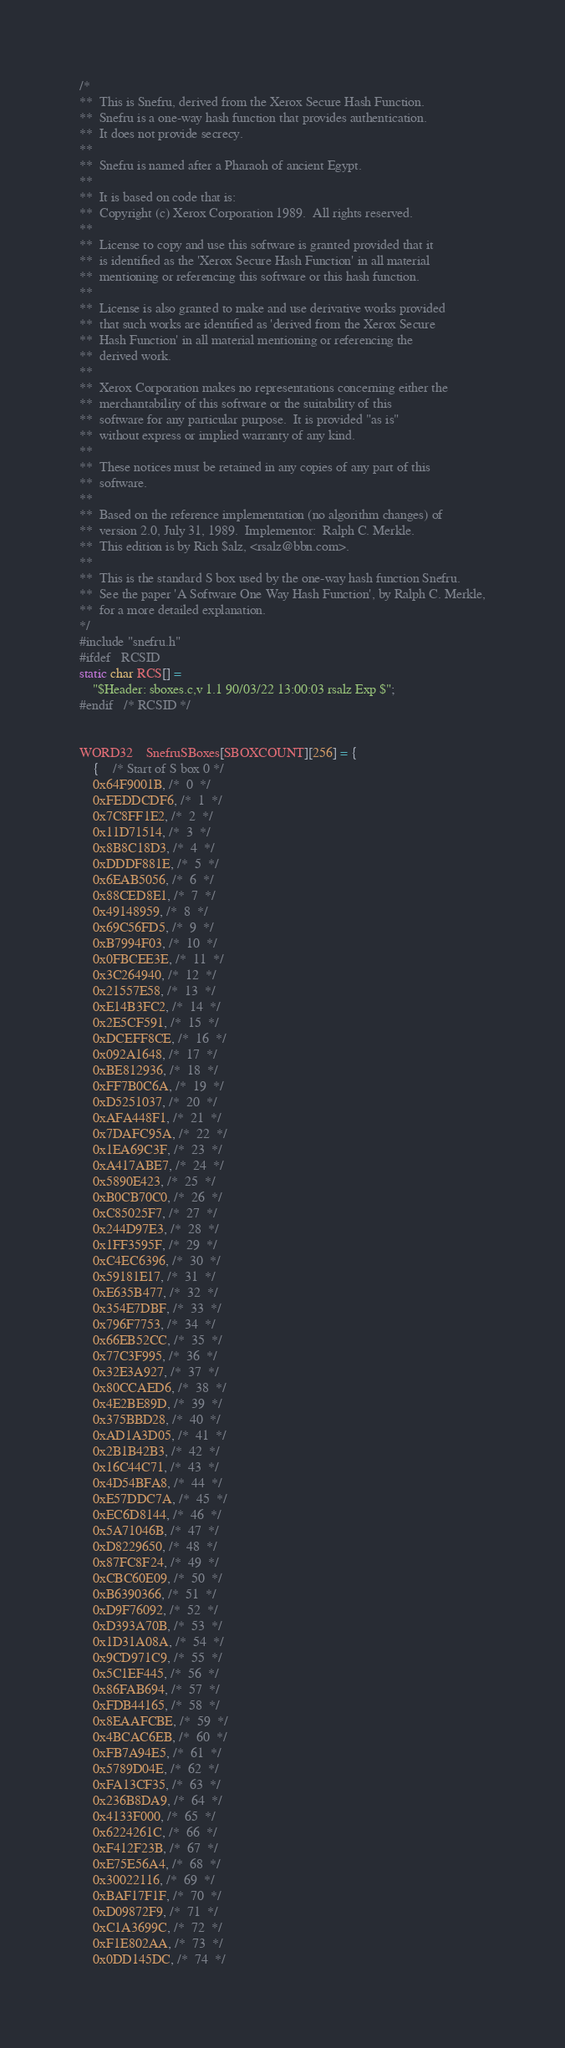<code> <loc_0><loc_0><loc_500><loc_500><_C_>/*
**  This is Snefru, derived from the Xerox Secure Hash Function.
**  Snefru is a one-way hash function that provides authentication.
**  It does not provide secrecy.
**
**  Snefru is named after a Pharaoh of ancient Egypt.
**
**  It is based on code that is:
**	Copyright (c) Xerox Corporation 1989.  All rights reserved.
**
**	License to copy and use this software is granted provided that it
**	is identified as the 'Xerox Secure Hash Function' in all material
**	mentioning or referencing this software or this hash function.
**
**	License is also granted to make and use derivative works provided
**	that such works are identified as 'derived from the Xerox Secure
**	Hash Function' in all material mentioning or referencing the
**	derived work.
**
**	Xerox Corporation makes no representations concerning either the
**	merchantability of this software or the suitability of this
**	software for any particular purpose.  It is provided "as is"
**	without express or implied warranty of any kind.
**
**	These notices must be retained in any copies of any part of this
**	software.
**
**  Based on the reference implementation (no algorithm changes) of
**  version 2.0, July 31, 1989.  Implementor:  Ralph C. Merkle.
**  This edition is by Rich $alz, <rsalz@bbn.com>.
**
**  This is the standard S box used by the one-way hash function Snefru.
**  See the paper 'A Software One Way Hash Function', by Ralph C. Merkle,
**  for a more detailed explanation.
*/
#include "snefru.h"
#ifdef	RCSID
static char RCS[] =
	"$Header: sboxes.c,v 1.1 90/03/22 13:00:03 rsalz Exp $";
#endif	/* RCSID */


WORD32	SnefruSBoxes[SBOXCOUNT][256] = {
    {	/* Start of S box 0 */
	0x64F9001B, /*  0  */
	0xFEDDCDF6, /*  1  */
	0x7C8FF1E2, /*  2  */
	0x11D71514, /*  3  */
	0x8B8C18D3, /*  4  */
	0xDDDF881E, /*  5  */
	0x6EAB5056, /*  6  */
	0x88CED8E1, /*  7  */
	0x49148959, /*  8  */
	0x69C56FD5, /*  9  */
	0xB7994F03, /*  10  */
	0x0FBCEE3E, /*  11  */
	0x3C264940, /*  12  */
	0x21557E58, /*  13  */
	0xE14B3FC2, /*  14  */
	0x2E5CF591, /*  15  */
	0xDCEFF8CE, /*  16  */
	0x092A1648, /*  17  */
	0xBE812936, /*  18  */
	0xFF7B0C6A, /*  19  */
	0xD5251037, /*  20  */
	0xAFA448F1, /*  21  */
	0x7DAFC95A, /*  22  */
	0x1EA69C3F, /*  23  */
	0xA417ABE7, /*  24  */
	0x5890E423, /*  25  */
	0xB0CB70C0, /*  26  */
	0xC85025F7, /*  27  */
	0x244D97E3, /*  28  */
	0x1FF3595F, /*  29  */
	0xC4EC6396, /*  30  */
	0x59181E17, /*  31  */
	0xE635B477, /*  32  */
	0x354E7DBF, /*  33  */
	0x796F7753, /*  34  */
	0x66EB52CC, /*  35  */
	0x77C3F995, /*  36  */
	0x32E3A927, /*  37  */
	0x80CCAED6, /*  38  */
	0x4E2BE89D, /*  39  */
	0x375BBD28, /*  40  */
	0xAD1A3D05, /*  41  */
	0x2B1B42B3, /*  42  */
	0x16C44C71, /*  43  */
	0x4D54BFA8, /*  44  */
	0xE57DDC7A, /*  45  */
	0xEC6D8144, /*  46  */
	0x5A71046B, /*  47  */
	0xD8229650, /*  48  */
	0x87FC8F24, /*  49  */
	0xCBC60E09, /*  50  */
	0xB6390366, /*  51  */
	0xD9F76092, /*  52  */
	0xD393A70B, /*  53  */
	0x1D31A08A, /*  54  */
	0x9CD971C9, /*  55  */
	0x5C1EF445, /*  56  */
	0x86FAB694, /*  57  */
	0xFDB44165, /*  58  */
	0x8EAAFCBE, /*  59  */
	0x4BCAC6EB, /*  60  */
	0xFB7A94E5, /*  61  */
	0x5789D04E, /*  62  */
	0xFA13CF35, /*  63  */
	0x236B8DA9, /*  64  */
	0x4133F000, /*  65  */
	0x6224261C, /*  66  */
	0xF412F23B, /*  67  */
	0xE75E56A4, /*  68  */
	0x30022116, /*  69  */
	0xBAF17F1F, /*  70  */
	0xD09872F9, /*  71  */
	0xC1A3699C, /*  72  */
	0xF1E802AA, /*  73  */
	0x0DD145DC, /*  74  */</code> 